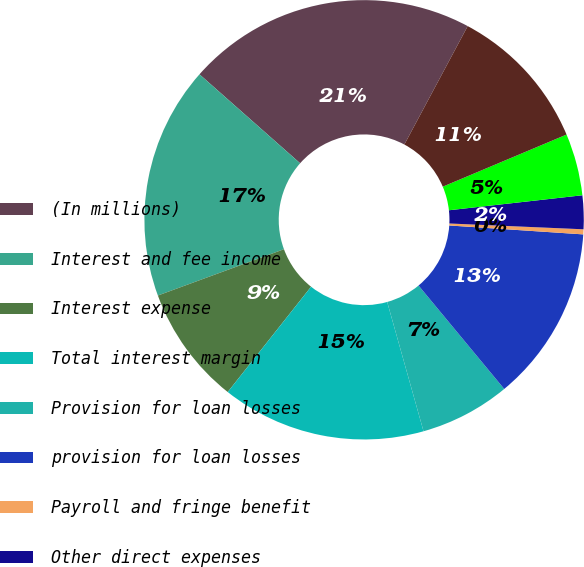Convert chart. <chart><loc_0><loc_0><loc_500><loc_500><pie_chart><fcel>(In millions)<fcel>Interest and fee income<fcel>Interest expense<fcel>Total interest margin<fcel>Provision for loan losses<fcel>provision for loan losses<fcel>Payroll and fringe benefit<fcel>Other direct expenses<fcel>Total direct expenses<fcel>CarMax Auto Finance income<nl><fcel>21.3%<fcel>17.12%<fcel>8.74%<fcel>15.02%<fcel>6.65%<fcel>12.93%<fcel>0.37%<fcel>2.47%<fcel>4.56%<fcel>10.84%<nl></chart> 